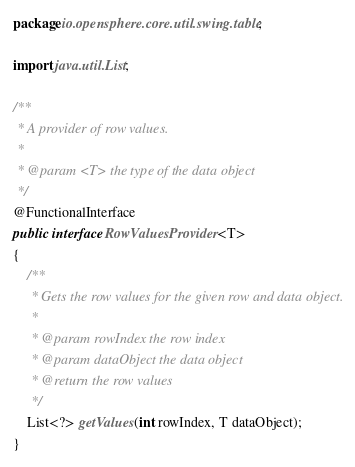<code> <loc_0><loc_0><loc_500><loc_500><_Java_>package io.opensphere.core.util.swing.table;

import java.util.List;

/**
 * A provider of row values.
 *
 * @param <T> the type of the data object
 */
@FunctionalInterface
public interface RowValuesProvider<T>
{
    /**
     * Gets the row values for the given row and data object.
     *
     * @param rowIndex the row index
     * @param dataObject the data object
     * @return the row values
     */
    List<?> getValues(int rowIndex, T dataObject);
}
</code> 